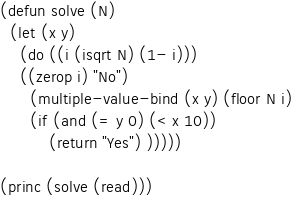Convert code to text. <code><loc_0><loc_0><loc_500><loc_500><_Lisp_>(defun solve (N)
  (let (x y)
    (do ((i (isqrt N) (1- i)))
	((zerop i) "No")
      (multiple-value-bind (x y) (floor N i)
	  (if (and (= y 0) (< x 10))
	      (return "Yes") )))))

(princ (solve (read)))</code> 